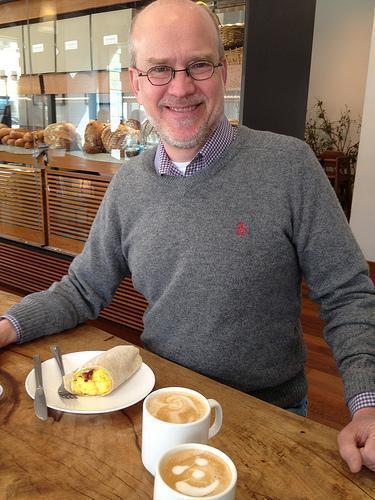How many cups of coffee?
Give a very brief answer. 2. 